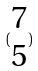Convert formula to latex. <formula><loc_0><loc_0><loc_500><loc_500>( \begin{matrix} 7 \\ 5 \end{matrix} )</formula> 